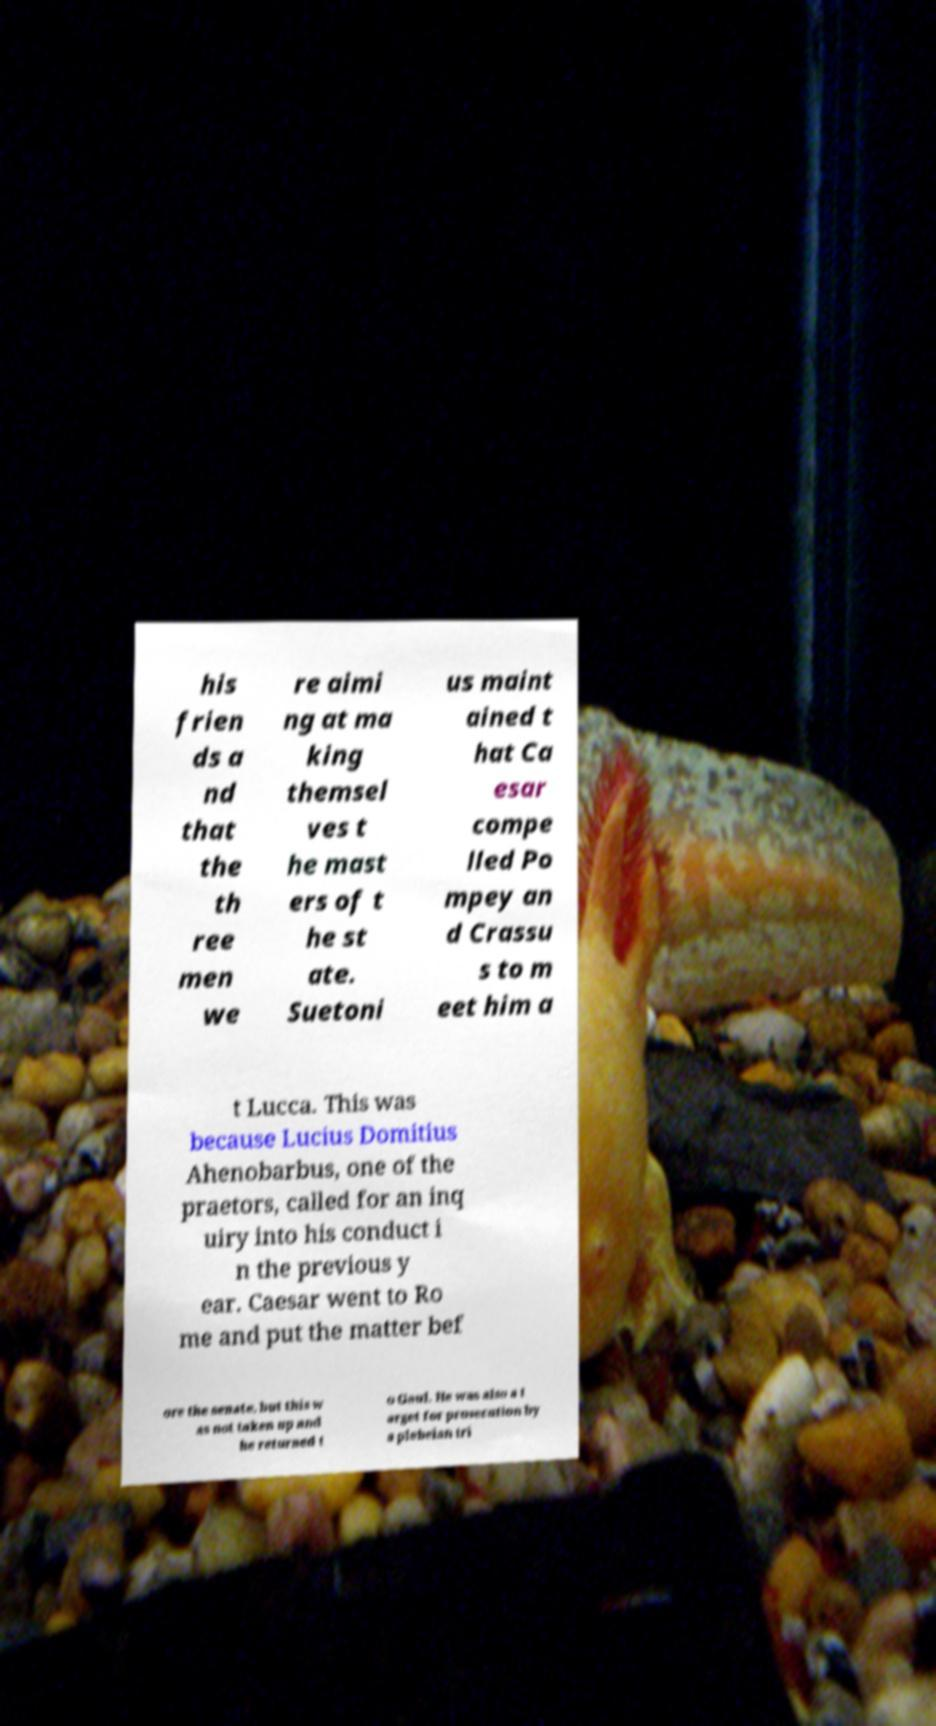Could you extract and type out the text from this image? his frien ds a nd that the th ree men we re aimi ng at ma king themsel ves t he mast ers of t he st ate. Suetoni us maint ained t hat Ca esar compe lled Po mpey an d Crassu s to m eet him a t Lucca. This was because Lucius Domitius Ahenobarbus, one of the praetors, called for an inq uiry into his conduct i n the previous y ear. Caesar went to Ro me and put the matter bef ore the senate, but this w as not taken up and he returned t o Gaul. He was also a t arget for prosecution by a plebeian tri 